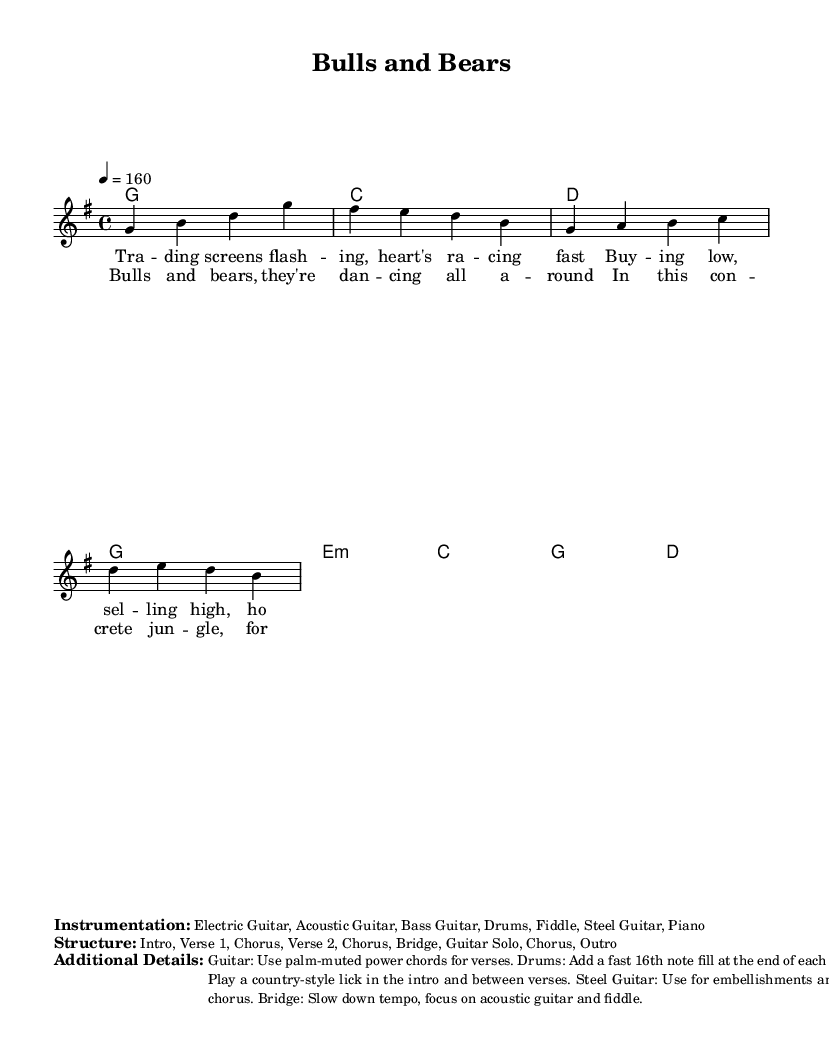What is the key signature of this music? The key signature is G major, indicated by one sharp (F#) which is present in the scales of the piece.
Answer: G major What is the time signature of the music? The time signature is 4/4, as represented in the score, indicating four beats per measure.
Answer: 4/4 What is the tempo marking used in this piece? The tempo marking is quarter note equals 160, indicating a fast-paced performance.
Answer: 160 How many measures are in the first verse? By counting the measures in the verse section in the score, there are four measures.
Answer: 4 What instruments are included in the instrumentation? The listed instruments are Electric Guitar, Acoustic Guitar, Bass Guitar, Drums, Fiddle, Steel Guitar, and Piano.
Answer: Electric Guitar, Acoustic Guitar, Bass Guitar, Drums, Fiddle, Steel Guitar, Piano What is the structure of the music? The structure is divided into several sections: Intro, Verse 1, Chorus, Verse 2, Chorus, Bridge, Guitar Solo, Chorus, Outro.
Answer: Intro, Verse 1, Chorus, Verse 2, Chorus, Bridge, Guitar Solo, Chorus, Outro What style of guitar playing is suggested for the verses? The suggested style for the verses is to use palm-muted power chords, which is a characteristic technique in country-rock music.
Answer: Palm-muted power chords 